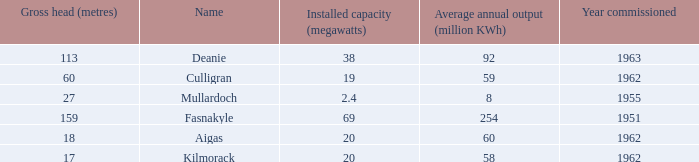What is the Average annual output for Culligran power station with an Installed capacity less than 19? None. 